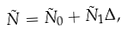Convert formula to latex. <formula><loc_0><loc_0><loc_500><loc_500>\tilde { N } = \tilde { N } _ { 0 } + \tilde { N } _ { 1 } \Delta ,</formula> 